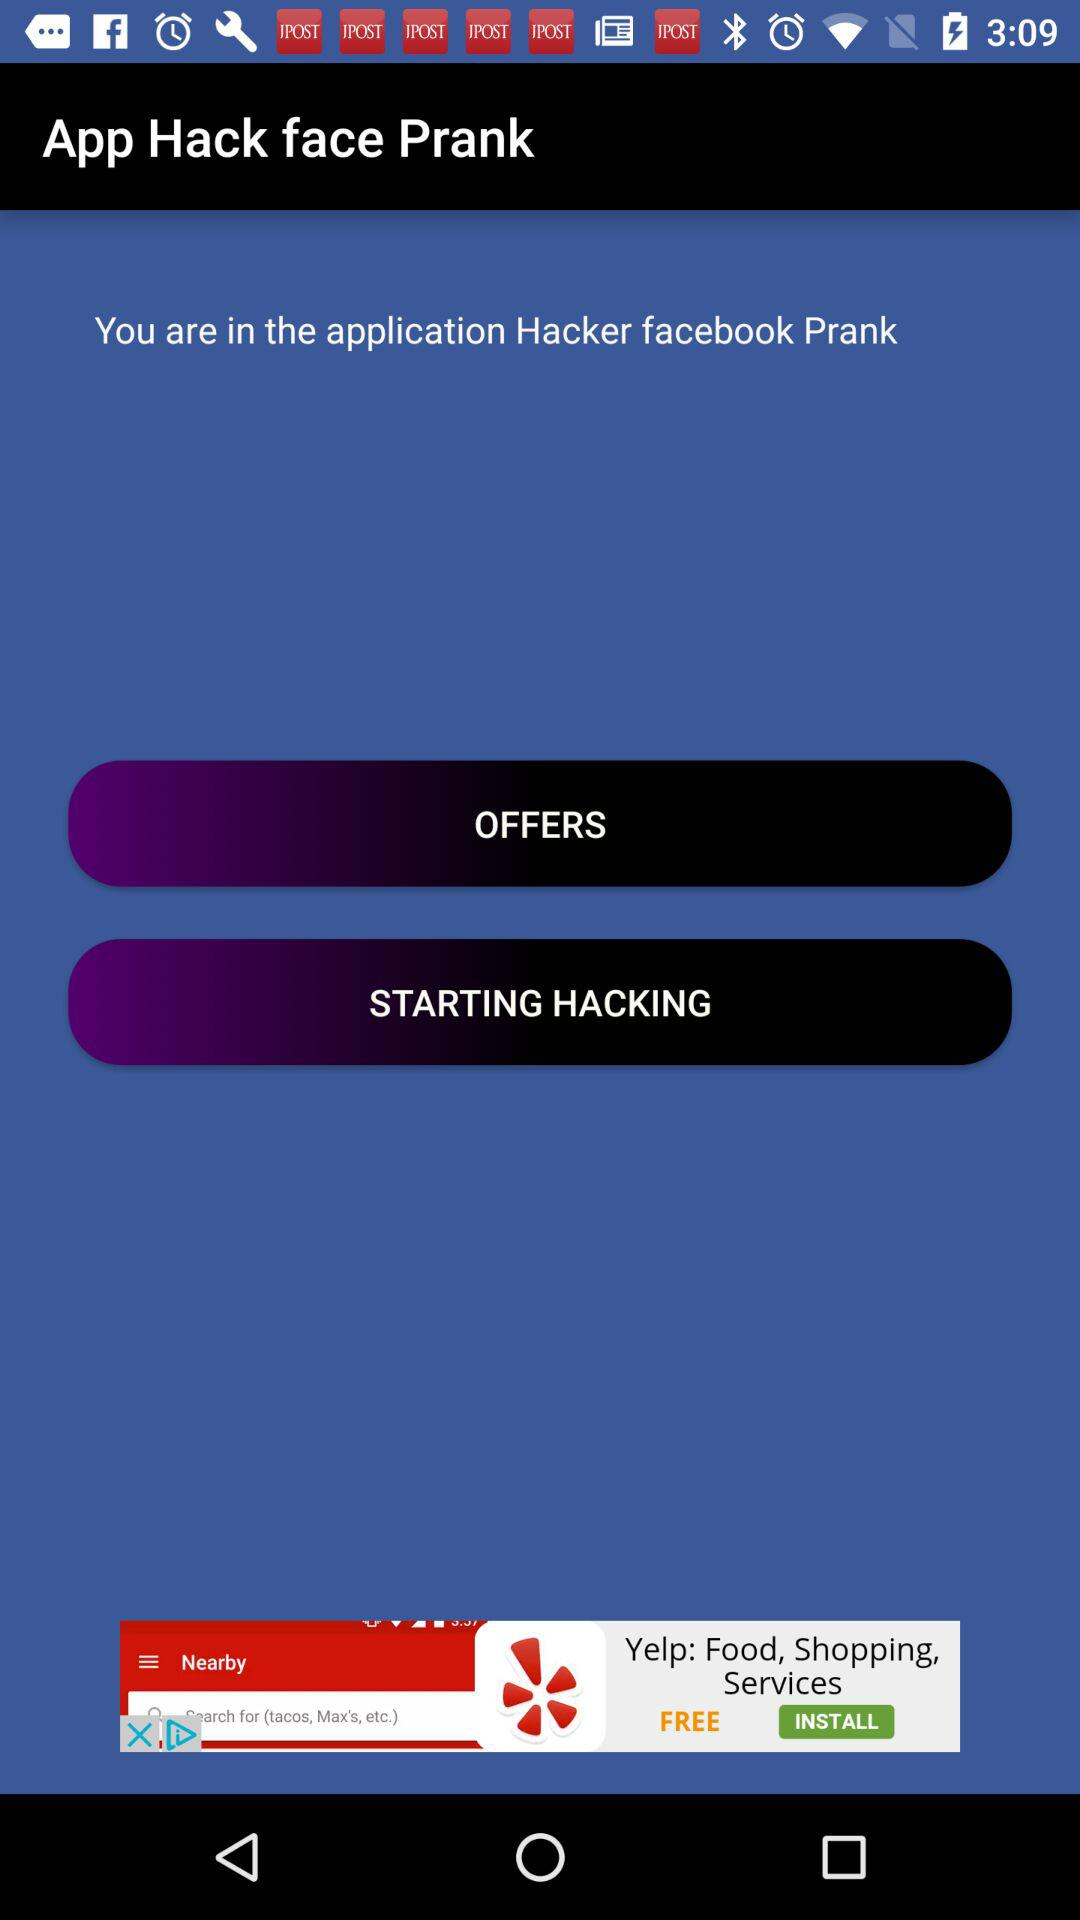What is the name of the application? The name of the application is "Hacker facebook Prank". 